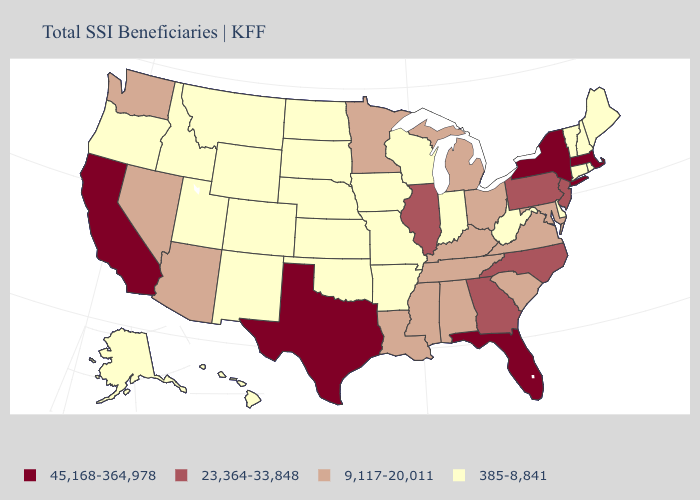Which states have the highest value in the USA?
Give a very brief answer. California, Florida, Massachusetts, New York, Texas. Name the states that have a value in the range 385-8,841?
Keep it brief. Alaska, Arkansas, Colorado, Connecticut, Delaware, Hawaii, Idaho, Indiana, Iowa, Kansas, Maine, Missouri, Montana, Nebraska, New Hampshire, New Mexico, North Dakota, Oklahoma, Oregon, Rhode Island, South Dakota, Utah, Vermont, West Virginia, Wisconsin, Wyoming. What is the lowest value in states that border Georgia?
Answer briefly. 9,117-20,011. What is the value of Oklahoma?
Give a very brief answer. 385-8,841. What is the value of Indiana?
Concise answer only. 385-8,841. What is the value of Georgia?
Quick response, please. 23,364-33,848. What is the value of Georgia?
Keep it brief. 23,364-33,848. What is the lowest value in the West?
Keep it brief. 385-8,841. Name the states that have a value in the range 385-8,841?
Be succinct. Alaska, Arkansas, Colorado, Connecticut, Delaware, Hawaii, Idaho, Indiana, Iowa, Kansas, Maine, Missouri, Montana, Nebraska, New Hampshire, New Mexico, North Dakota, Oklahoma, Oregon, Rhode Island, South Dakota, Utah, Vermont, West Virginia, Wisconsin, Wyoming. What is the value of West Virginia?
Concise answer only. 385-8,841. Which states have the lowest value in the USA?
Short answer required. Alaska, Arkansas, Colorado, Connecticut, Delaware, Hawaii, Idaho, Indiana, Iowa, Kansas, Maine, Missouri, Montana, Nebraska, New Hampshire, New Mexico, North Dakota, Oklahoma, Oregon, Rhode Island, South Dakota, Utah, Vermont, West Virginia, Wisconsin, Wyoming. What is the lowest value in states that border West Virginia?
Write a very short answer. 9,117-20,011. What is the highest value in the MidWest ?
Keep it brief. 23,364-33,848. What is the value of California?
Concise answer only. 45,168-364,978. What is the value of Alaska?
Short answer required. 385-8,841. 